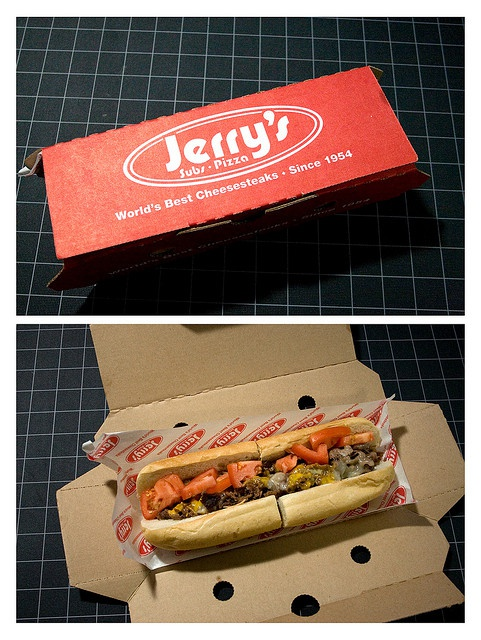Describe the objects in this image and their specific colors. I can see dining table in white, black, gray, purple, and darkblue tones, dining table in white, black, gray, and purple tones, and sandwich in white, tan, olive, and maroon tones in this image. 